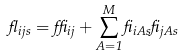Convert formula to latex. <formula><loc_0><loc_0><loc_500><loc_500>\gamma _ { i j s } = \delta _ { i j } + \sum _ { A = 1 } ^ { M } \beta _ { i A s } \beta _ { j A s }</formula> 